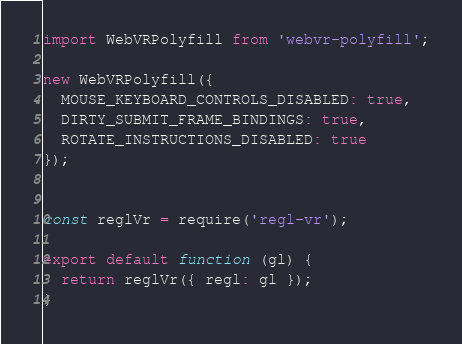Convert code to text. <code><loc_0><loc_0><loc_500><loc_500><_JavaScript_>import WebVRPolyfill from 'webvr-polyfill';

new WebVRPolyfill({
  MOUSE_KEYBOARD_CONTROLS_DISABLED: true,
  DIRTY_SUBMIT_FRAME_BINDINGS: true,
  ROTATE_INSTRUCTIONS_DISABLED: true
});


const reglVr = require('regl-vr');

export default function (gl) {
  return reglVr({ regl: gl });
}
</code> 